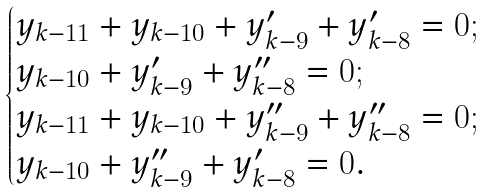Convert formula to latex. <formula><loc_0><loc_0><loc_500><loc_500>\begin{cases} y _ { k - 1 1 } + y _ { k - 1 0 } + y _ { k - 9 } ^ { \prime } + y _ { k - 8 } ^ { \prime } = 0 ; \\ y _ { k - 1 0 } + y _ { k - 9 } ^ { \prime } + y _ { k - 8 } ^ { \prime \prime } = 0 ; \\ y _ { k - 1 1 } + y _ { k - 1 0 } + y _ { k - 9 } ^ { \prime \prime } + y _ { k - 8 } ^ { \prime \prime } = 0 ; \\ y _ { k - 1 0 } + y _ { k - 9 } ^ { \prime \prime } + y _ { k - 8 } ^ { \prime } = 0 . \end{cases}</formula> 